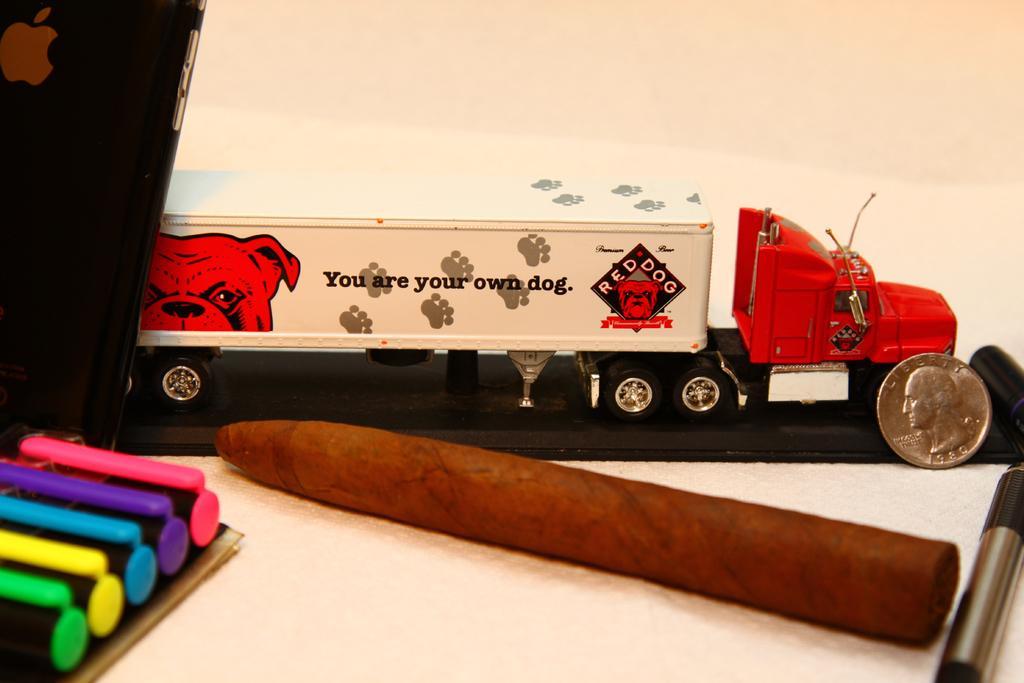Please provide a concise description of this image. In this image I can see a toy truck, a coin, a pen, a brown colour thing over here, a black colour phone and here I can see few markers. I can also see something is written over here. 